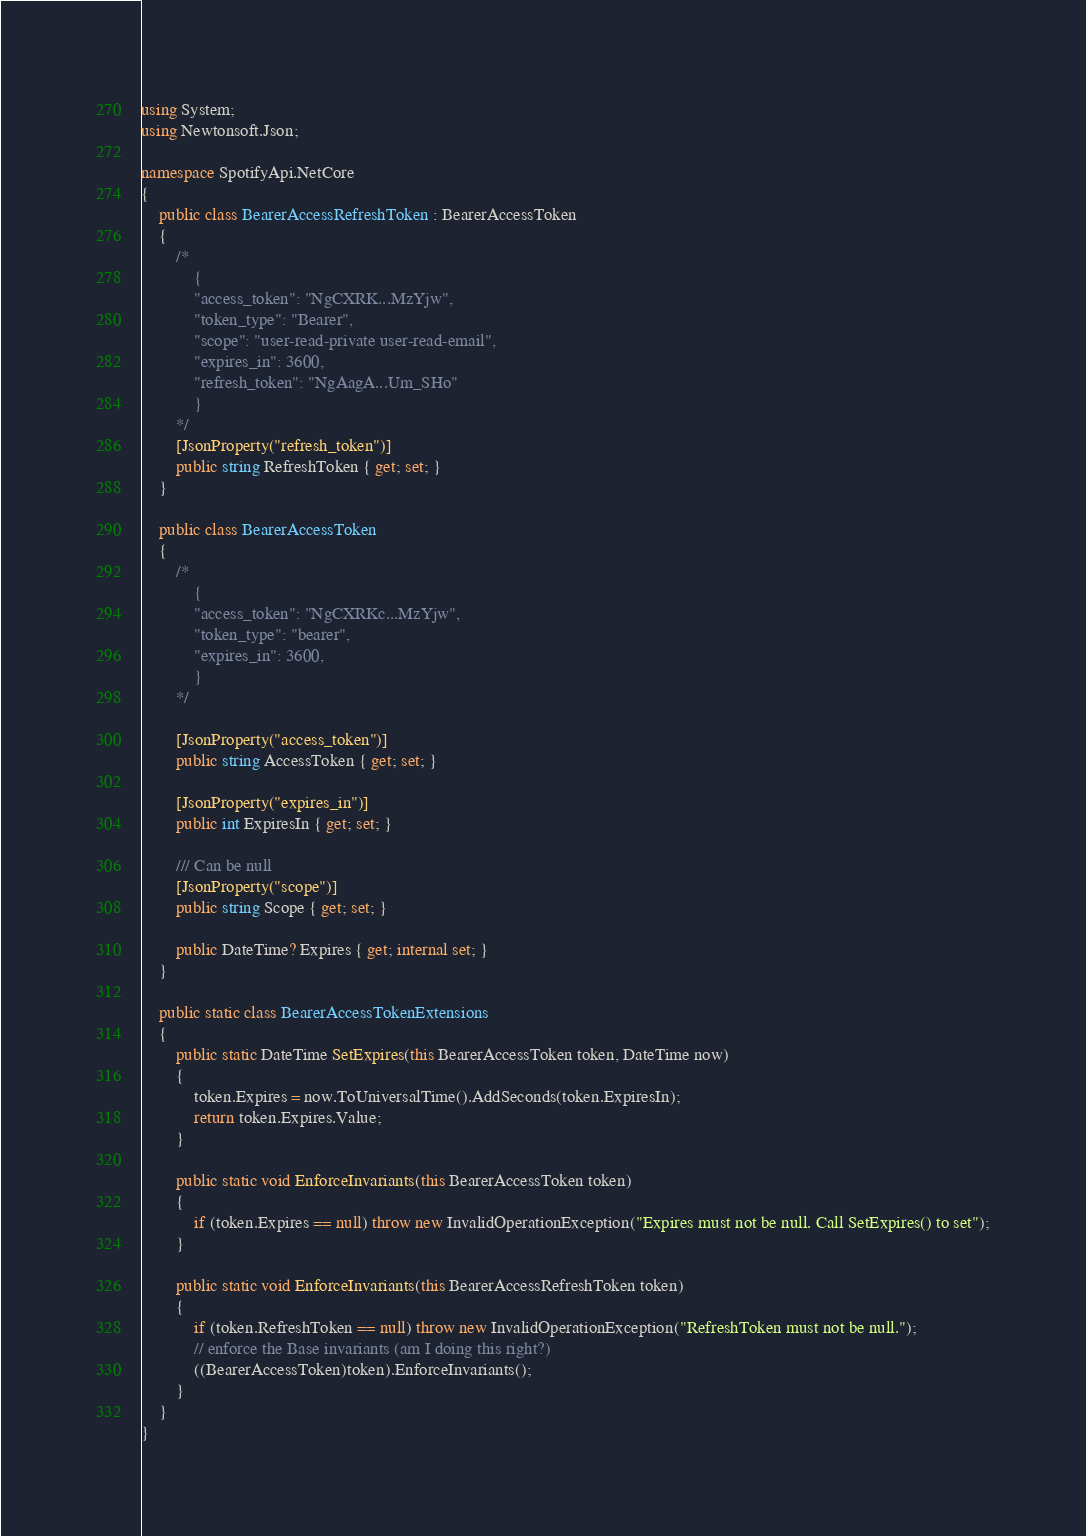Convert code to text. <code><loc_0><loc_0><loc_500><loc_500><_C#_>using System;
using Newtonsoft.Json;

namespace SpotifyApi.NetCore
{
    public class BearerAccessRefreshToken : BearerAccessToken
    {
        /*
            {
            "access_token": "NgCXRK...MzYjw",
            "token_type": "Bearer",
            "scope": "user-read-private user-read-email",
            "expires_in": 3600,
            "refresh_token": "NgAagA...Um_SHo"
            }        
        */
        [JsonProperty("refresh_token")]
        public string RefreshToken { get; set; }
    }

    public class BearerAccessToken
    {
        /*
            {
            "access_token": "NgCXRKc...MzYjw",
            "token_type": "bearer",
            "expires_in": 3600,
            }
        */        

        [JsonProperty("access_token")]
        public string AccessToken { get; set; }

        [JsonProperty("expires_in")]
        public int ExpiresIn { get; set; }

        /// Can be null
        [JsonProperty("scope")]
        public string Scope { get; set; }

        public DateTime? Expires { get; internal set; }
    }

    public static class BearerAccessTokenExtensions
    {
        public static DateTime SetExpires(this BearerAccessToken token, DateTime now)
        {
            token.Expires = now.ToUniversalTime().AddSeconds(token.ExpiresIn);
            return token.Expires.Value;
        }

        public static void EnforceInvariants(this BearerAccessToken token)
        {
            if (token.Expires == null) throw new InvalidOperationException("Expires must not be null. Call SetExpires() to set");
        }

        public static void EnforceInvariants(this BearerAccessRefreshToken token)
        {
            if (token.RefreshToken == null) throw new InvalidOperationException("RefreshToken must not be null.");
            // enforce the Base invariants (am I doing this right?)
            ((BearerAccessToken)token).EnforceInvariants();
        }
    }
}</code> 